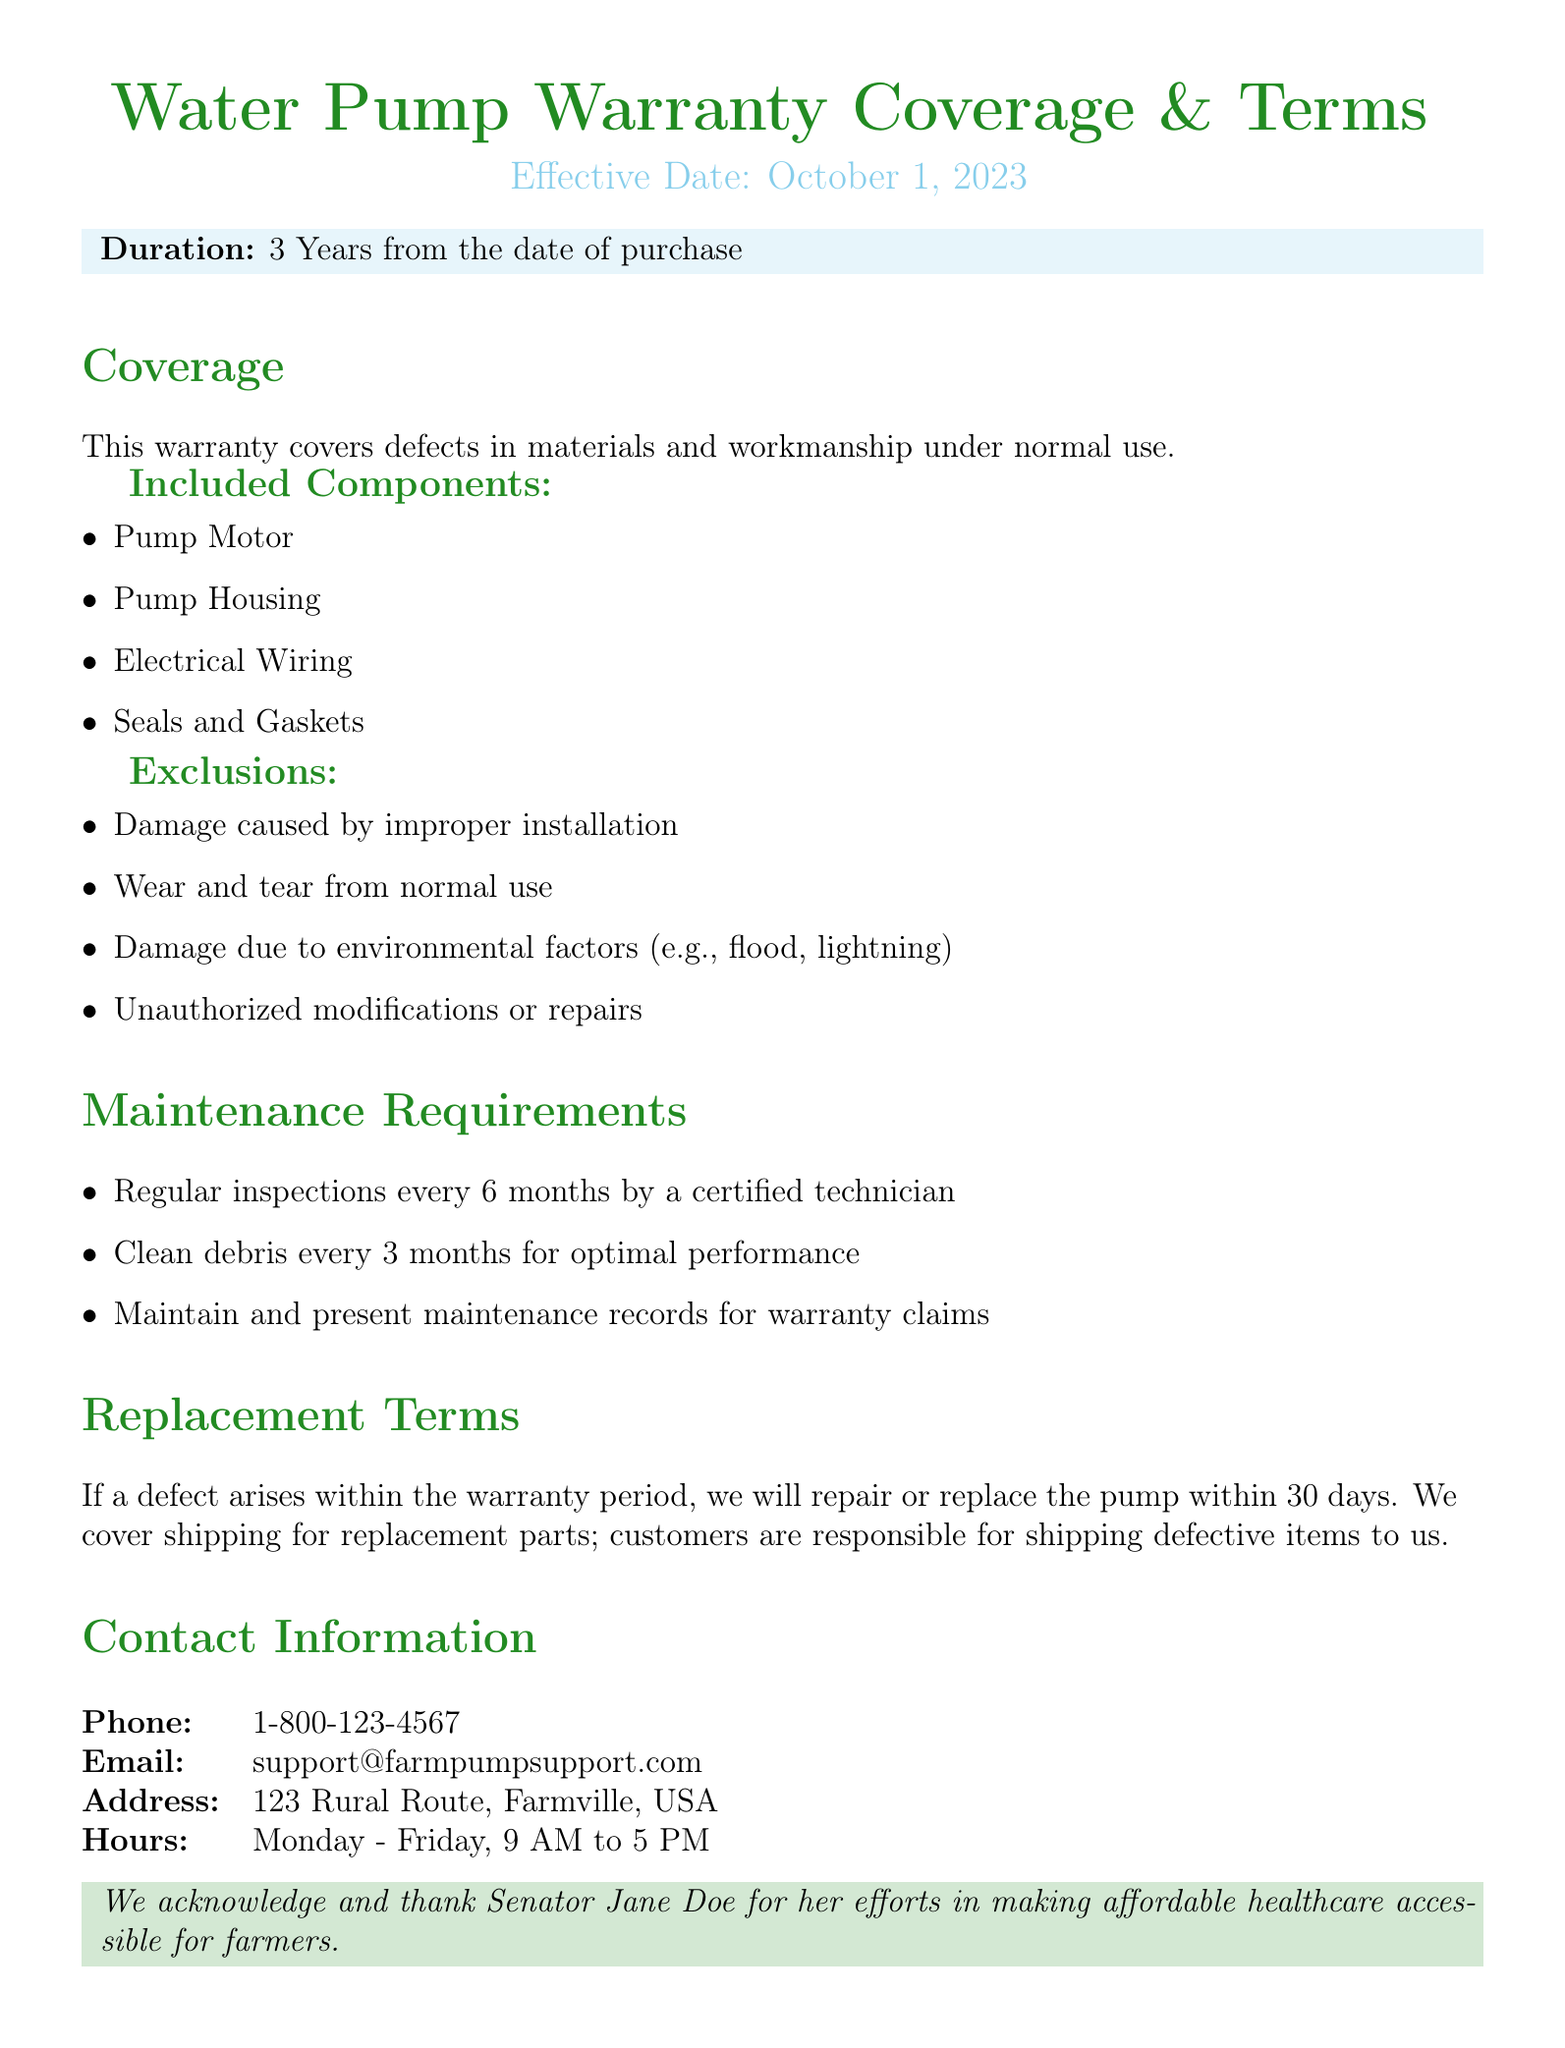What is the duration of the warranty? The duration of the warranty is specified in the document as 3 years from the date of purchase.
Answer: 3 Years When does the warranty become effective? The effective date of the warranty is clearly stated in the document.
Answer: October 1, 2023 Who should perform regular inspections? The document specifies who should perform the inspections as certified technicians.
Answer: Certified technician What is included in the warranty coverage? The document lists the components that are included in the warranty coverage.
Answer: Pump Motor, Pump Housing, Electrical Wiring, Seals and Gaskets What are customers responsible for regarding shipping? The document outlines what customers must cover in terms of shipping for warranty claims.
Answer: Shipping defective items to us What type of damage is excluded from coverage? The document states specific exclusions related to the warranty coverage.
Answer: Damage caused by improper installation How often should inspections be conducted? The document specifies the frequency of the inspections required for maintenance.
Answer: Every 6 months What happens if a defect arises within the warranty period? The document explains the actions taken if defects arise within the warranty period.
Answer: We will repair or replace the pump within 30 days What is the contact email for support? The document provides the email address for customer support inquiries.
Answer: support@farmpumpsupport.com What is mentioned about Senator Jane Doe? The document includes a thank you message directed to a specific person regarding healthcare efforts.
Answer: Acknowledge and thank Senator Jane Doe for her efforts in making affordable healthcare accessible for farmers 